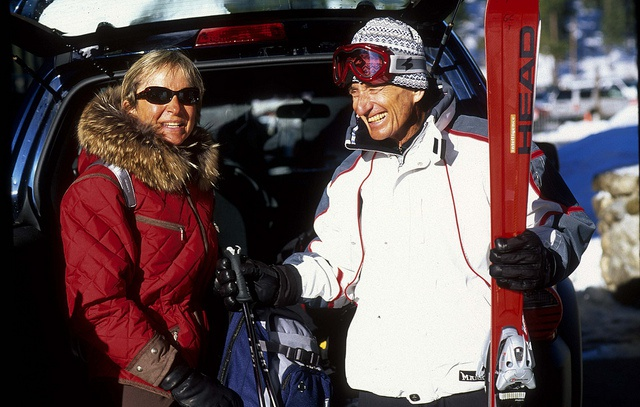Describe the objects in this image and their specific colors. I can see car in black, white, gray, and navy tones, people in black, white, gray, and darkgray tones, people in black, brown, and maroon tones, skis in black, brown, lightgray, and maroon tones, and backpack in black, navy, darkgray, and gray tones in this image. 